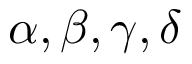Convert formula to latex. <formula><loc_0><loc_0><loc_500><loc_500>\alpha , \beta , \gamma , \delta</formula> 